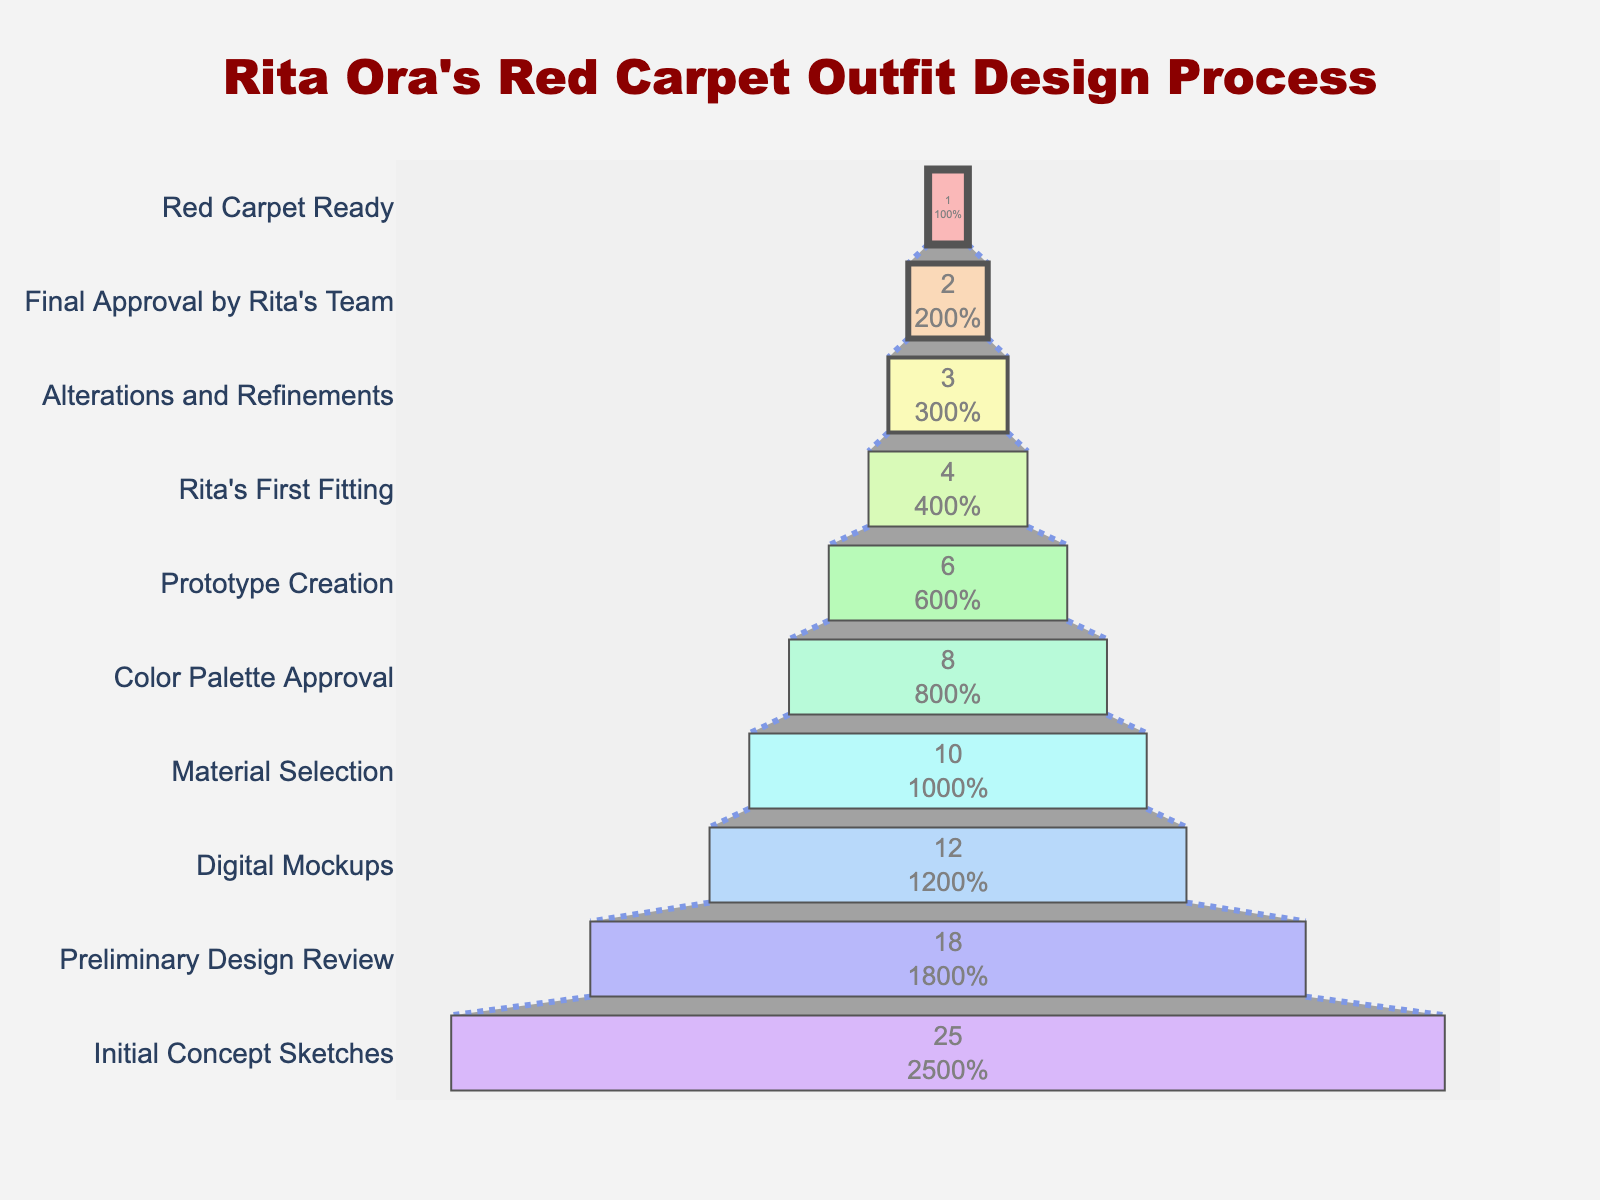What is the title of the figure? The title is usually positioned at the top of the figure. When we look at the top, we can see the title text.
Answer: "Rita Ora's Red Carpet Outfit Design Process" How many stages are included in the design process? To find the number of stages, count the total number of unique stages listed on the y-axis. There are 10 stages.
Answer: 10 At which stage does the number of designs reduce the most? Compare the drop in the number of designs between each stage. The largest reduction occurs between the Initial Concept Sketches (25) and Preliminary Design Review (18), a reduction of 7 designs.
Answer: Initial Concept Sketches to Preliminary Design Review What percentage of designs make it past the Preliminary Design Review? Divide the number of designs in Digital Mockups (12) by the number of designs in Initial Concept Sketches (25) and multiply by 100 to get the percentage.
Answer: 48% How many designs are approved for the red carpet look? Look at the final stage labeled "Red Carpet Ready". The number of designs at this stage is 1.
Answer: 1 What is the reduction in the number of designs from Prototype Creation to Rita’s First Fitting? Subtract the number of designs at Rita’s First Fitting (4) from Prototype Creation (6), which is 2 designs.
Answer: 2 Which stage shows the smallest reduction in the number of designs? Compare the reductions between each stage. The smallest reduction occurs between Alterations and Refinements (3) and Final Approval by Rita’s Team (2), a reduction of just 1 design.
Answer: Alterations and Refinements to Final Approval by Rita’s Team How many designs are eliminated between Material Selection and Color Palette Approval? Subtract the number of designs in Color Palette Approval (8) from Material Selection (10). The number eliminated is 2.
Answer: 2 Do more designs get eliminated initially or towards the end of the process? Compare the number eliminated initially (Initial Concept Sketches 25 to Digital Mockups 12, which is 13 designs) with the number eliminated towards the end (Rita's First Fitting 4 to Red Carpet Ready 1, which is 3 designs). More designs are eliminated initially.
Answer: Initially 